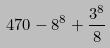Convert formula to latex. <formula><loc_0><loc_0><loc_500><loc_500>4 7 0 - 8 ^ { 8 } + \frac { 3 ^ { 8 } } { 8 }</formula> 